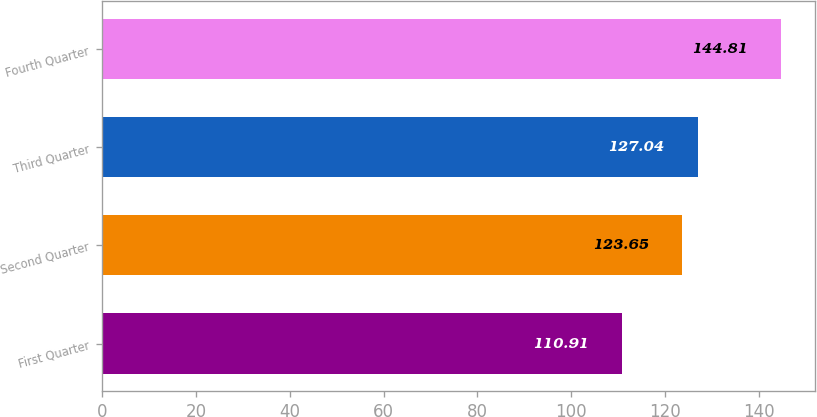Convert chart. <chart><loc_0><loc_0><loc_500><loc_500><bar_chart><fcel>First Quarter<fcel>Second Quarter<fcel>Third Quarter<fcel>Fourth Quarter<nl><fcel>110.91<fcel>123.65<fcel>127.04<fcel>144.81<nl></chart> 